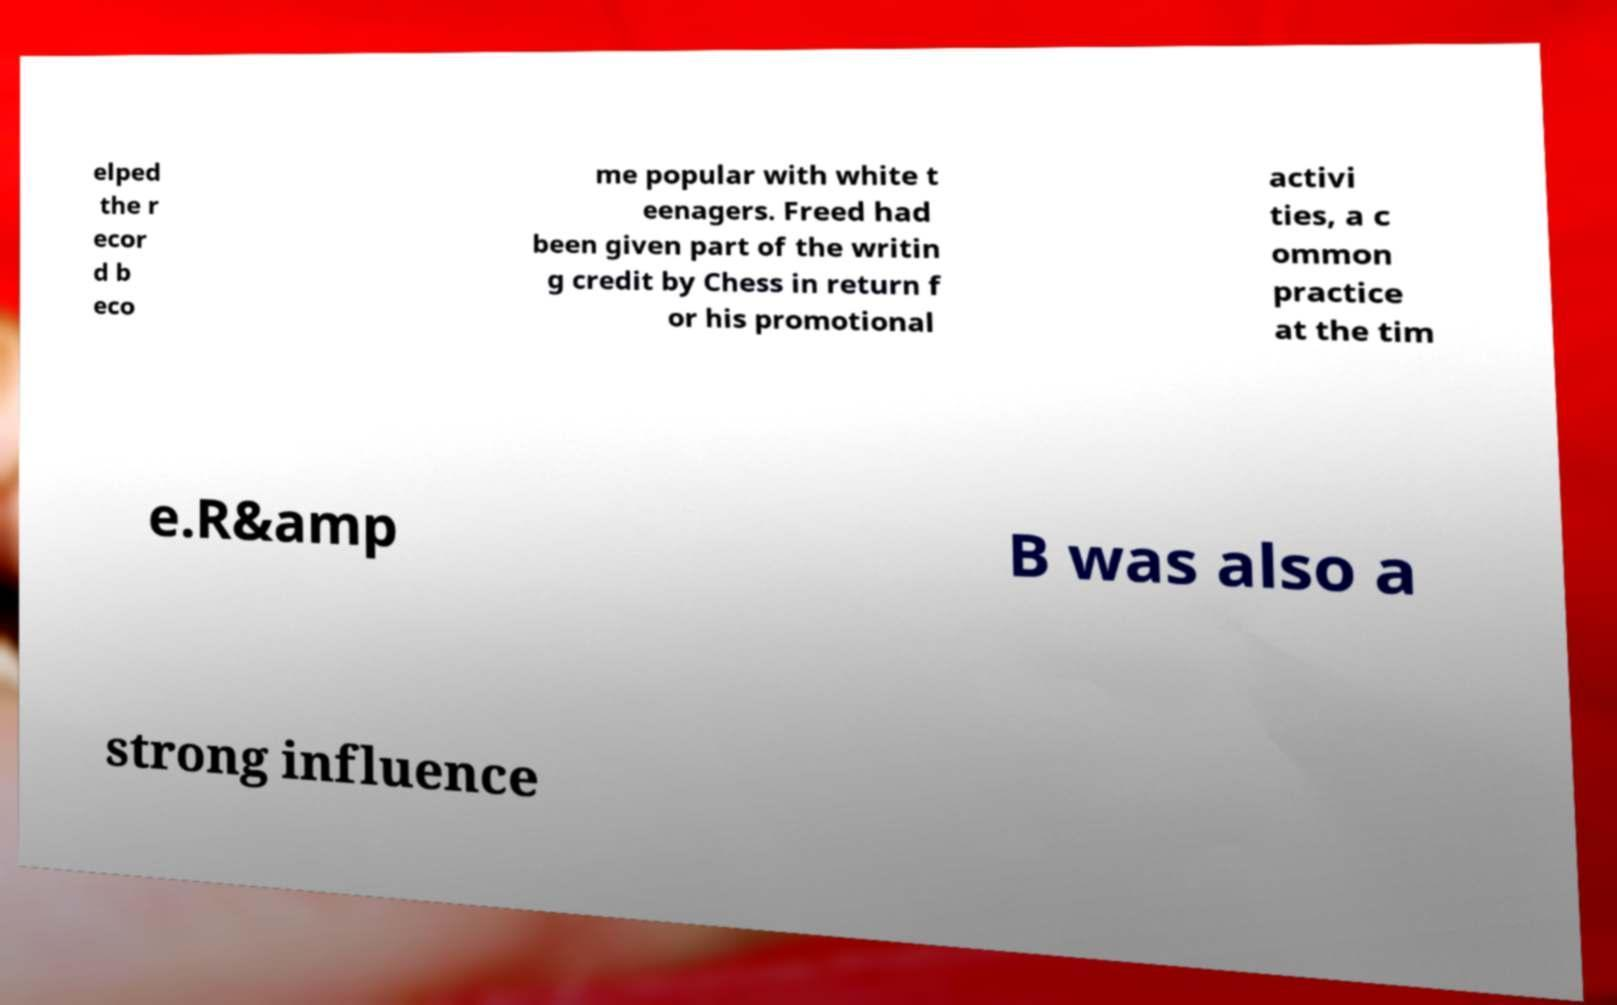Could you extract and type out the text from this image? elped the r ecor d b eco me popular with white t eenagers. Freed had been given part of the writin g credit by Chess in return f or his promotional activi ties, a c ommon practice at the tim e.R&amp B was also a strong influence 